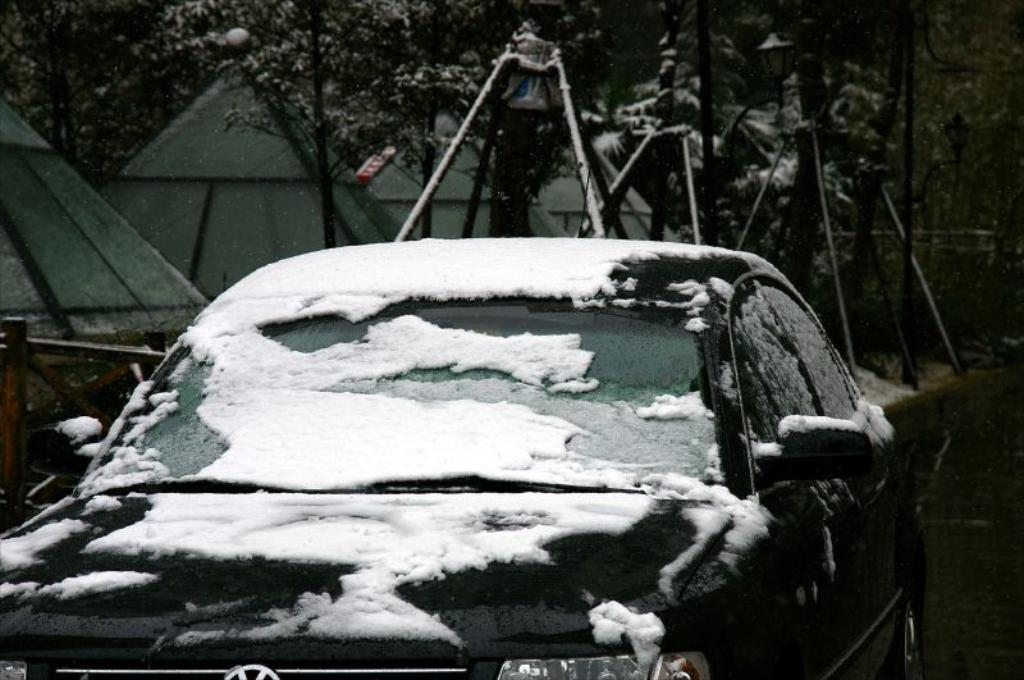What is the main subject of the image? There is a car in the image. How is the car affected by the weather? The car is covered by snow. What can be seen in the background of the image? There are seeds and trees in the background of the image. What is at the bottom of the image? There is a road at the bottom of the image. What unit of measurement is used to weigh the mark on the car's windshield? There is no mark on the car's windshield in the image, and therefore no weight or unit of measurement can be determined. 